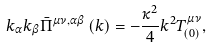<formula> <loc_0><loc_0><loc_500><loc_500>k _ { \alpha } k _ { \beta } \bar { \Pi } ^ { \mu \nu , \alpha \beta } \left ( k \right ) = - \frac { \kappa ^ { 2 } } 4 k ^ { 2 } T _ { \left ( 0 \right ) } ^ { \mu \nu } ,</formula> 